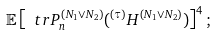<formula> <loc_0><loc_0><loc_500><loc_500>\mathbb { E } \left [ \ t r P _ { n } ^ { ( N _ { 1 } \vee N _ { 2 } ) } ( ^ { ( \tau ) } H ^ { ( N _ { 1 } \vee N _ { 2 } ) } ) \right ] ^ { 4 } ;</formula> 